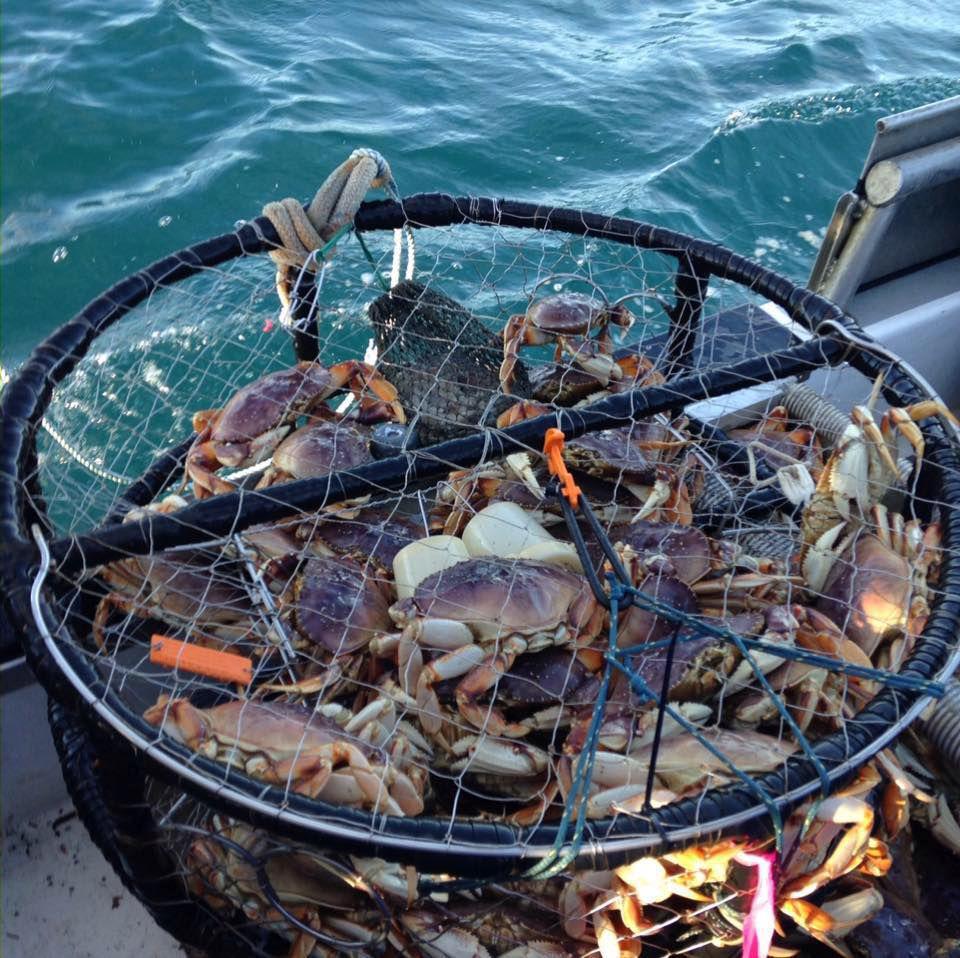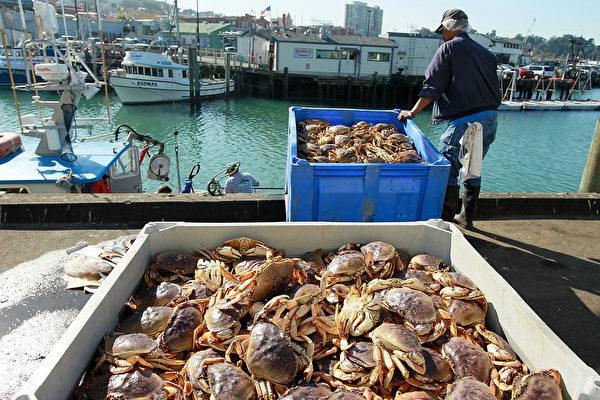The first image is the image on the left, the second image is the image on the right. Considering the images on both sides, is "All of the baskets holding the crabs are circular." valid? Answer yes or no. No. The first image is the image on the left, the second image is the image on the right. Considering the images on both sides, is "All the crabs are in cages." valid? Answer yes or no. No. 